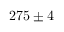Convert formula to latex. <formula><loc_0><loc_0><loc_500><loc_500>{ 2 7 5 \pm 4 }</formula> 